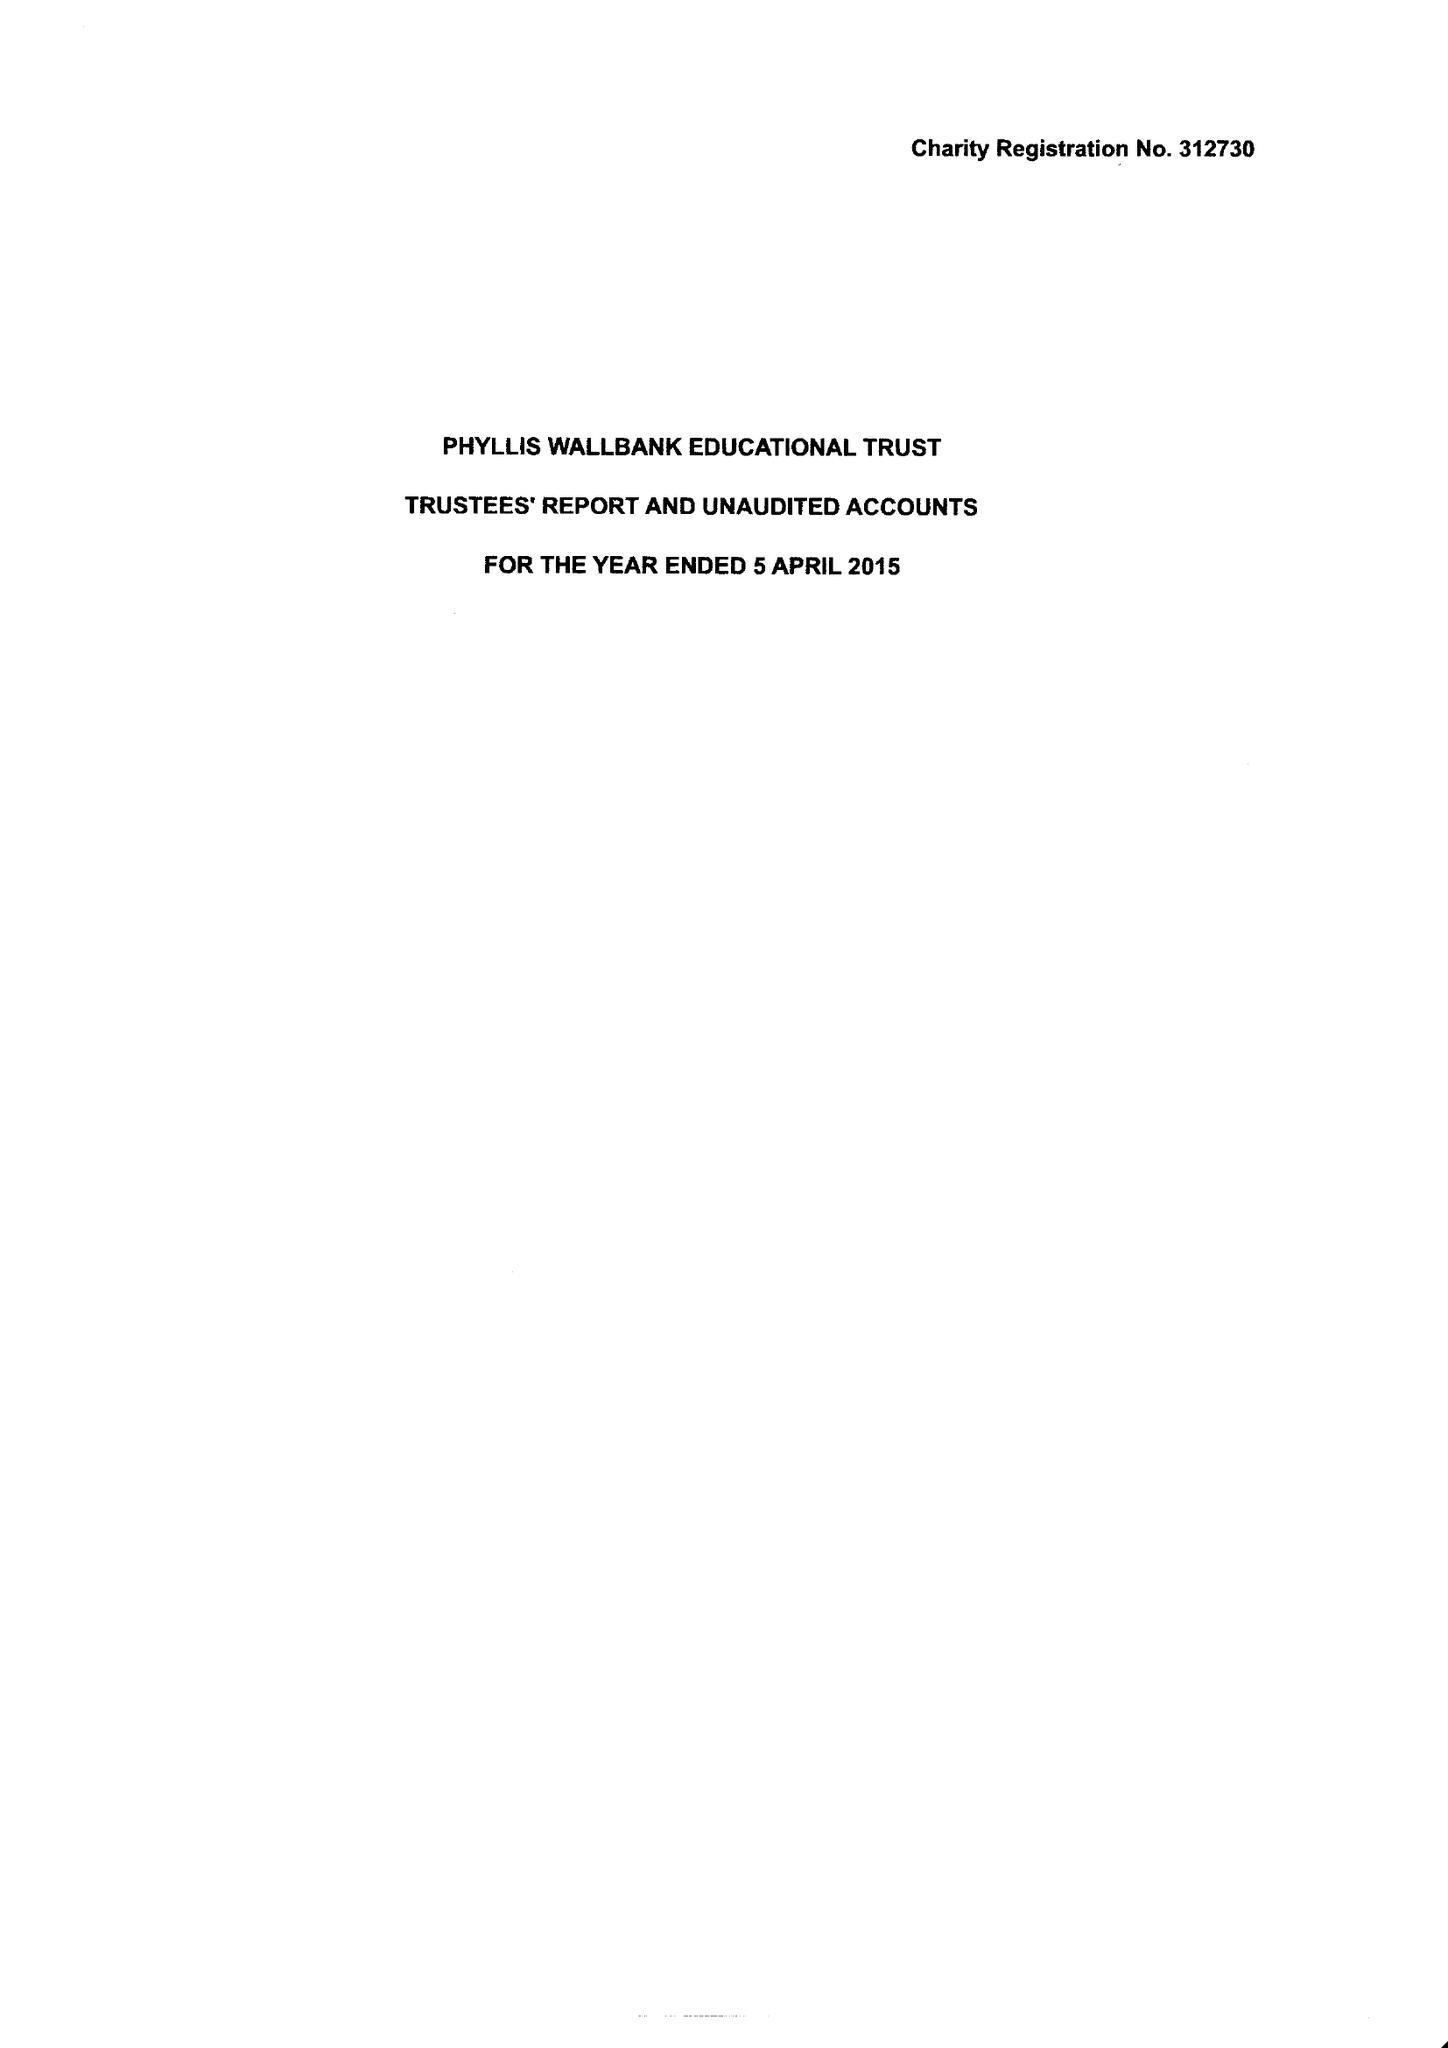What is the value for the address__post_town?
Answer the question using a single word or phrase. LONDON 